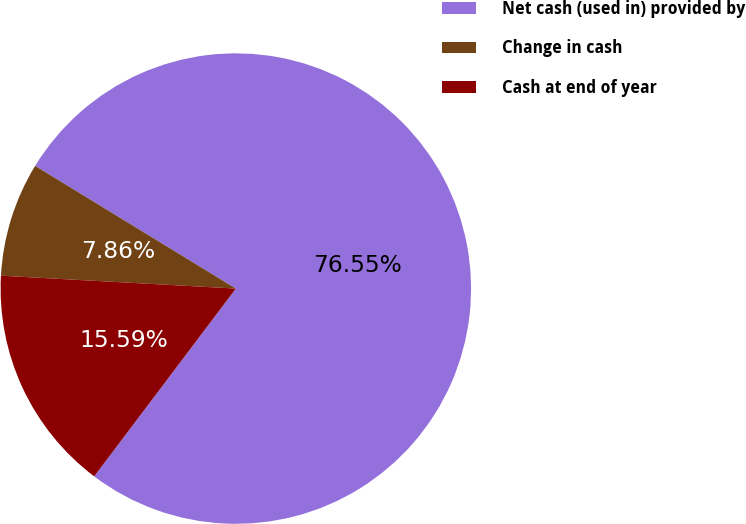Convert chart. <chart><loc_0><loc_0><loc_500><loc_500><pie_chart><fcel>Net cash (used in) provided by<fcel>Change in cash<fcel>Cash at end of year<nl><fcel>76.55%<fcel>7.86%<fcel>15.59%<nl></chart> 